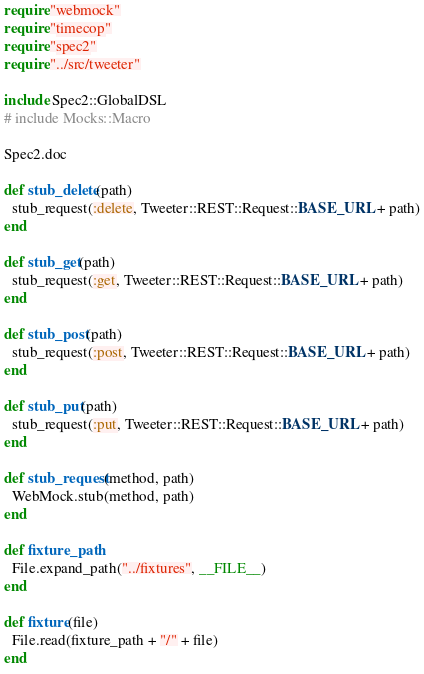<code> <loc_0><loc_0><loc_500><loc_500><_Crystal_>require "webmock"
require "timecop"
require "spec2"
require "../src/tweeter"

include Spec2::GlobalDSL
# include Mocks::Macro

Spec2.doc

def stub_delete(path)
  stub_request(:delete, Tweeter::REST::Request::BASE_URL + path)
end

def stub_get(path)
  stub_request(:get, Tweeter::REST::Request::BASE_URL + path)
end

def stub_post(path)
  stub_request(:post, Tweeter::REST::Request::BASE_URL + path)
end

def stub_put(path)
  stub_request(:put, Tweeter::REST::Request::BASE_URL + path)
end

def stub_request(method, path)
  WebMock.stub(method, path)
end

def fixture_path
  File.expand_path("../fixtures", __FILE__)
end

def fixture(file)
  File.read(fixture_path + "/" + file)
end
</code> 